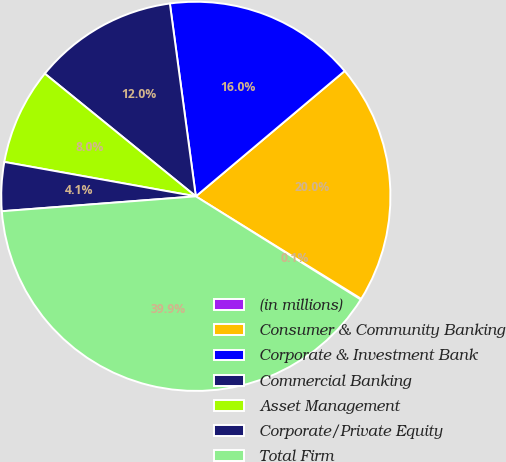Convert chart. <chart><loc_0><loc_0><loc_500><loc_500><pie_chart><fcel>(in millions)<fcel>Consumer & Community Banking<fcel>Corporate & Investment Bank<fcel>Commercial Banking<fcel>Asset Management<fcel>Corporate/Private Equity<fcel>Total Firm<nl><fcel>0.07%<fcel>19.97%<fcel>15.99%<fcel>12.01%<fcel>8.03%<fcel>4.05%<fcel>39.88%<nl></chart> 